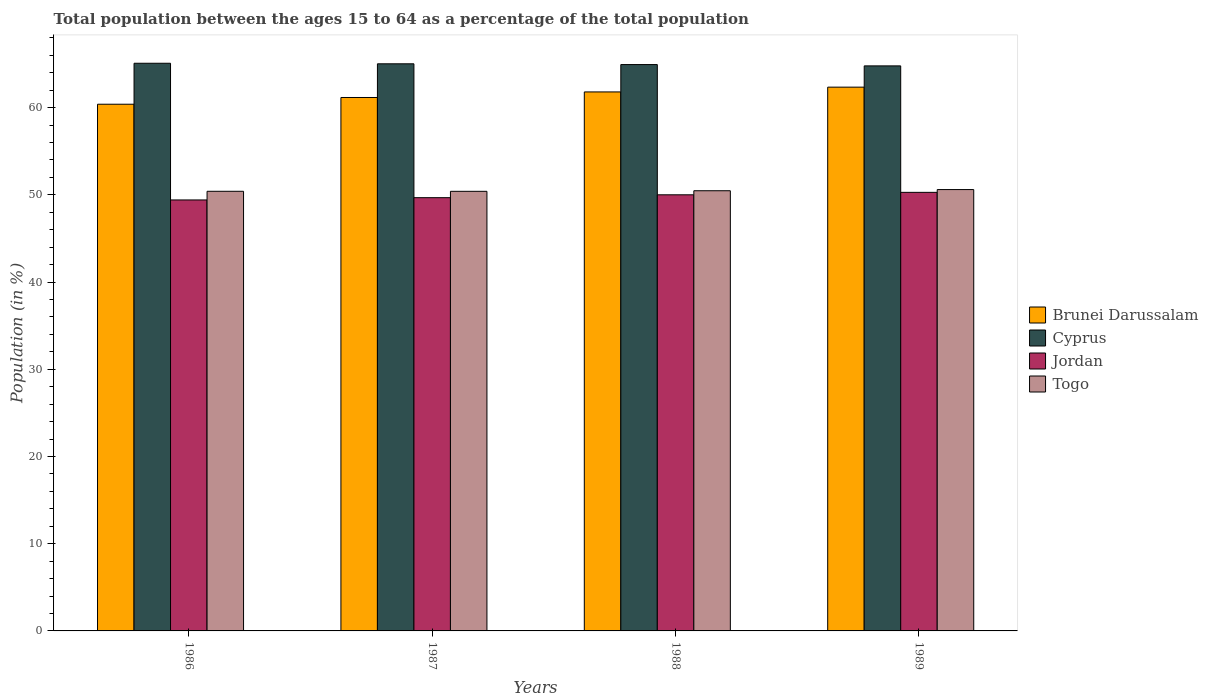How many different coloured bars are there?
Provide a short and direct response. 4. How many groups of bars are there?
Provide a short and direct response. 4. Are the number of bars on each tick of the X-axis equal?
Offer a terse response. Yes. What is the label of the 3rd group of bars from the left?
Keep it short and to the point. 1988. What is the percentage of the population ages 15 to 64 in Togo in 1986?
Make the answer very short. 50.4. Across all years, what is the maximum percentage of the population ages 15 to 64 in Jordan?
Ensure brevity in your answer.  50.28. Across all years, what is the minimum percentage of the population ages 15 to 64 in Jordan?
Offer a terse response. 49.41. In which year was the percentage of the population ages 15 to 64 in Togo minimum?
Your response must be concise. 1987. What is the total percentage of the population ages 15 to 64 in Togo in the graph?
Your response must be concise. 201.87. What is the difference between the percentage of the population ages 15 to 64 in Togo in 1987 and that in 1988?
Offer a very short reply. -0.07. What is the difference between the percentage of the population ages 15 to 64 in Brunei Darussalam in 1986 and the percentage of the population ages 15 to 64 in Togo in 1988?
Your answer should be very brief. 9.92. What is the average percentage of the population ages 15 to 64 in Jordan per year?
Provide a succinct answer. 49.84. In the year 1986, what is the difference between the percentage of the population ages 15 to 64 in Jordan and percentage of the population ages 15 to 64 in Togo?
Offer a terse response. -0.99. What is the ratio of the percentage of the population ages 15 to 64 in Brunei Darussalam in 1987 to that in 1988?
Offer a very short reply. 0.99. Is the percentage of the population ages 15 to 64 in Jordan in 1986 less than that in 1988?
Provide a short and direct response. Yes. What is the difference between the highest and the second highest percentage of the population ages 15 to 64 in Jordan?
Your answer should be very brief. 0.28. What is the difference between the highest and the lowest percentage of the population ages 15 to 64 in Jordan?
Offer a terse response. 0.87. In how many years, is the percentage of the population ages 15 to 64 in Jordan greater than the average percentage of the population ages 15 to 64 in Jordan taken over all years?
Offer a terse response. 2. Is it the case that in every year, the sum of the percentage of the population ages 15 to 64 in Jordan and percentage of the population ages 15 to 64 in Brunei Darussalam is greater than the sum of percentage of the population ages 15 to 64 in Togo and percentage of the population ages 15 to 64 in Cyprus?
Keep it short and to the point. Yes. What does the 2nd bar from the left in 1988 represents?
Provide a short and direct response. Cyprus. What does the 2nd bar from the right in 1986 represents?
Offer a very short reply. Jordan. Is it the case that in every year, the sum of the percentage of the population ages 15 to 64 in Togo and percentage of the population ages 15 to 64 in Jordan is greater than the percentage of the population ages 15 to 64 in Brunei Darussalam?
Give a very brief answer. Yes. How many years are there in the graph?
Ensure brevity in your answer.  4. Are the values on the major ticks of Y-axis written in scientific E-notation?
Provide a succinct answer. No. Does the graph contain any zero values?
Give a very brief answer. No. Where does the legend appear in the graph?
Give a very brief answer. Center right. How many legend labels are there?
Ensure brevity in your answer.  4. How are the legend labels stacked?
Make the answer very short. Vertical. What is the title of the graph?
Offer a terse response. Total population between the ages 15 to 64 as a percentage of the total population. What is the label or title of the X-axis?
Give a very brief answer. Years. What is the label or title of the Y-axis?
Offer a very short reply. Population (in %). What is the Population (in %) of Brunei Darussalam in 1986?
Provide a succinct answer. 60.38. What is the Population (in %) of Cyprus in 1986?
Make the answer very short. 65.08. What is the Population (in %) in Jordan in 1986?
Ensure brevity in your answer.  49.41. What is the Population (in %) in Togo in 1986?
Keep it short and to the point. 50.4. What is the Population (in %) of Brunei Darussalam in 1987?
Provide a succinct answer. 61.16. What is the Population (in %) of Cyprus in 1987?
Offer a terse response. 65.02. What is the Population (in %) in Jordan in 1987?
Offer a terse response. 49.67. What is the Population (in %) of Togo in 1987?
Provide a succinct answer. 50.4. What is the Population (in %) in Brunei Darussalam in 1988?
Your response must be concise. 61.79. What is the Population (in %) in Cyprus in 1988?
Give a very brief answer. 64.93. What is the Population (in %) in Jordan in 1988?
Provide a short and direct response. 50. What is the Population (in %) in Togo in 1988?
Ensure brevity in your answer.  50.47. What is the Population (in %) in Brunei Darussalam in 1989?
Offer a very short reply. 62.34. What is the Population (in %) of Cyprus in 1989?
Your response must be concise. 64.78. What is the Population (in %) in Jordan in 1989?
Your response must be concise. 50.28. What is the Population (in %) of Togo in 1989?
Make the answer very short. 50.6. Across all years, what is the maximum Population (in %) in Brunei Darussalam?
Ensure brevity in your answer.  62.34. Across all years, what is the maximum Population (in %) of Cyprus?
Your response must be concise. 65.08. Across all years, what is the maximum Population (in %) of Jordan?
Keep it short and to the point. 50.28. Across all years, what is the maximum Population (in %) in Togo?
Your answer should be compact. 50.6. Across all years, what is the minimum Population (in %) of Brunei Darussalam?
Offer a terse response. 60.38. Across all years, what is the minimum Population (in %) in Cyprus?
Your response must be concise. 64.78. Across all years, what is the minimum Population (in %) of Jordan?
Keep it short and to the point. 49.41. Across all years, what is the minimum Population (in %) in Togo?
Give a very brief answer. 50.4. What is the total Population (in %) in Brunei Darussalam in the graph?
Ensure brevity in your answer.  245.68. What is the total Population (in %) of Cyprus in the graph?
Offer a terse response. 259.81. What is the total Population (in %) of Jordan in the graph?
Offer a terse response. 199.36. What is the total Population (in %) of Togo in the graph?
Offer a very short reply. 201.87. What is the difference between the Population (in %) of Brunei Darussalam in 1986 and that in 1987?
Keep it short and to the point. -0.77. What is the difference between the Population (in %) of Cyprus in 1986 and that in 1987?
Offer a terse response. 0.06. What is the difference between the Population (in %) in Jordan in 1986 and that in 1987?
Give a very brief answer. -0.26. What is the difference between the Population (in %) in Togo in 1986 and that in 1987?
Your response must be concise. 0. What is the difference between the Population (in %) in Brunei Darussalam in 1986 and that in 1988?
Your response must be concise. -1.41. What is the difference between the Population (in %) of Cyprus in 1986 and that in 1988?
Give a very brief answer. 0.15. What is the difference between the Population (in %) in Jordan in 1986 and that in 1988?
Give a very brief answer. -0.59. What is the difference between the Population (in %) of Togo in 1986 and that in 1988?
Keep it short and to the point. -0.06. What is the difference between the Population (in %) of Brunei Darussalam in 1986 and that in 1989?
Offer a terse response. -1.96. What is the difference between the Population (in %) in Cyprus in 1986 and that in 1989?
Give a very brief answer. 0.3. What is the difference between the Population (in %) in Jordan in 1986 and that in 1989?
Ensure brevity in your answer.  -0.87. What is the difference between the Population (in %) of Togo in 1986 and that in 1989?
Your answer should be compact. -0.2. What is the difference between the Population (in %) in Brunei Darussalam in 1987 and that in 1988?
Ensure brevity in your answer.  -0.64. What is the difference between the Population (in %) of Cyprus in 1987 and that in 1988?
Give a very brief answer. 0.09. What is the difference between the Population (in %) in Jordan in 1987 and that in 1988?
Ensure brevity in your answer.  -0.33. What is the difference between the Population (in %) in Togo in 1987 and that in 1988?
Ensure brevity in your answer.  -0.07. What is the difference between the Population (in %) in Brunei Darussalam in 1987 and that in 1989?
Offer a very short reply. -1.18. What is the difference between the Population (in %) of Cyprus in 1987 and that in 1989?
Provide a short and direct response. 0.24. What is the difference between the Population (in %) of Jordan in 1987 and that in 1989?
Your answer should be very brief. -0.61. What is the difference between the Population (in %) of Togo in 1987 and that in 1989?
Keep it short and to the point. -0.2. What is the difference between the Population (in %) of Brunei Darussalam in 1988 and that in 1989?
Offer a terse response. -0.55. What is the difference between the Population (in %) in Cyprus in 1988 and that in 1989?
Give a very brief answer. 0.15. What is the difference between the Population (in %) in Jordan in 1988 and that in 1989?
Provide a succinct answer. -0.28. What is the difference between the Population (in %) in Togo in 1988 and that in 1989?
Offer a very short reply. -0.13. What is the difference between the Population (in %) of Brunei Darussalam in 1986 and the Population (in %) of Cyprus in 1987?
Keep it short and to the point. -4.64. What is the difference between the Population (in %) in Brunei Darussalam in 1986 and the Population (in %) in Jordan in 1987?
Your answer should be compact. 10.71. What is the difference between the Population (in %) of Brunei Darussalam in 1986 and the Population (in %) of Togo in 1987?
Provide a short and direct response. 9.98. What is the difference between the Population (in %) in Cyprus in 1986 and the Population (in %) in Jordan in 1987?
Your answer should be compact. 15.41. What is the difference between the Population (in %) in Cyprus in 1986 and the Population (in %) in Togo in 1987?
Provide a short and direct response. 14.68. What is the difference between the Population (in %) in Jordan in 1986 and the Population (in %) in Togo in 1987?
Give a very brief answer. -0.99. What is the difference between the Population (in %) in Brunei Darussalam in 1986 and the Population (in %) in Cyprus in 1988?
Your answer should be compact. -4.55. What is the difference between the Population (in %) of Brunei Darussalam in 1986 and the Population (in %) of Jordan in 1988?
Provide a succinct answer. 10.38. What is the difference between the Population (in %) of Brunei Darussalam in 1986 and the Population (in %) of Togo in 1988?
Offer a very short reply. 9.92. What is the difference between the Population (in %) in Cyprus in 1986 and the Population (in %) in Jordan in 1988?
Offer a terse response. 15.08. What is the difference between the Population (in %) in Cyprus in 1986 and the Population (in %) in Togo in 1988?
Ensure brevity in your answer.  14.62. What is the difference between the Population (in %) in Jordan in 1986 and the Population (in %) in Togo in 1988?
Provide a short and direct response. -1.06. What is the difference between the Population (in %) in Brunei Darussalam in 1986 and the Population (in %) in Cyprus in 1989?
Offer a very short reply. -4.4. What is the difference between the Population (in %) in Brunei Darussalam in 1986 and the Population (in %) in Jordan in 1989?
Offer a terse response. 10.1. What is the difference between the Population (in %) in Brunei Darussalam in 1986 and the Population (in %) in Togo in 1989?
Ensure brevity in your answer.  9.78. What is the difference between the Population (in %) of Cyprus in 1986 and the Population (in %) of Jordan in 1989?
Make the answer very short. 14.8. What is the difference between the Population (in %) in Cyprus in 1986 and the Population (in %) in Togo in 1989?
Your answer should be very brief. 14.48. What is the difference between the Population (in %) in Jordan in 1986 and the Population (in %) in Togo in 1989?
Offer a very short reply. -1.19. What is the difference between the Population (in %) in Brunei Darussalam in 1987 and the Population (in %) in Cyprus in 1988?
Provide a succinct answer. -3.77. What is the difference between the Population (in %) of Brunei Darussalam in 1987 and the Population (in %) of Jordan in 1988?
Ensure brevity in your answer.  11.16. What is the difference between the Population (in %) in Brunei Darussalam in 1987 and the Population (in %) in Togo in 1988?
Keep it short and to the point. 10.69. What is the difference between the Population (in %) in Cyprus in 1987 and the Population (in %) in Jordan in 1988?
Your answer should be very brief. 15.02. What is the difference between the Population (in %) in Cyprus in 1987 and the Population (in %) in Togo in 1988?
Provide a succinct answer. 14.55. What is the difference between the Population (in %) of Jordan in 1987 and the Population (in %) of Togo in 1988?
Ensure brevity in your answer.  -0.79. What is the difference between the Population (in %) of Brunei Darussalam in 1987 and the Population (in %) of Cyprus in 1989?
Give a very brief answer. -3.62. What is the difference between the Population (in %) in Brunei Darussalam in 1987 and the Population (in %) in Jordan in 1989?
Give a very brief answer. 10.88. What is the difference between the Population (in %) in Brunei Darussalam in 1987 and the Population (in %) in Togo in 1989?
Provide a succinct answer. 10.56. What is the difference between the Population (in %) of Cyprus in 1987 and the Population (in %) of Jordan in 1989?
Your response must be concise. 14.74. What is the difference between the Population (in %) in Cyprus in 1987 and the Population (in %) in Togo in 1989?
Give a very brief answer. 14.42. What is the difference between the Population (in %) in Jordan in 1987 and the Population (in %) in Togo in 1989?
Provide a succinct answer. -0.93. What is the difference between the Population (in %) in Brunei Darussalam in 1988 and the Population (in %) in Cyprus in 1989?
Ensure brevity in your answer.  -2.99. What is the difference between the Population (in %) in Brunei Darussalam in 1988 and the Population (in %) in Jordan in 1989?
Keep it short and to the point. 11.51. What is the difference between the Population (in %) of Brunei Darussalam in 1988 and the Population (in %) of Togo in 1989?
Keep it short and to the point. 11.19. What is the difference between the Population (in %) of Cyprus in 1988 and the Population (in %) of Jordan in 1989?
Ensure brevity in your answer.  14.65. What is the difference between the Population (in %) in Cyprus in 1988 and the Population (in %) in Togo in 1989?
Provide a succinct answer. 14.33. What is the difference between the Population (in %) in Jordan in 1988 and the Population (in %) in Togo in 1989?
Ensure brevity in your answer.  -0.6. What is the average Population (in %) of Brunei Darussalam per year?
Ensure brevity in your answer.  61.42. What is the average Population (in %) in Cyprus per year?
Provide a short and direct response. 64.95. What is the average Population (in %) of Jordan per year?
Provide a short and direct response. 49.84. What is the average Population (in %) in Togo per year?
Provide a succinct answer. 50.47. In the year 1986, what is the difference between the Population (in %) of Brunei Darussalam and Population (in %) of Cyprus?
Offer a terse response. -4.7. In the year 1986, what is the difference between the Population (in %) in Brunei Darussalam and Population (in %) in Jordan?
Make the answer very short. 10.97. In the year 1986, what is the difference between the Population (in %) in Brunei Darussalam and Population (in %) in Togo?
Your answer should be very brief. 9.98. In the year 1986, what is the difference between the Population (in %) in Cyprus and Population (in %) in Jordan?
Provide a succinct answer. 15.67. In the year 1986, what is the difference between the Population (in %) of Cyprus and Population (in %) of Togo?
Ensure brevity in your answer.  14.68. In the year 1986, what is the difference between the Population (in %) of Jordan and Population (in %) of Togo?
Give a very brief answer. -0.99. In the year 1987, what is the difference between the Population (in %) in Brunei Darussalam and Population (in %) in Cyprus?
Your answer should be compact. -3.86. In the year 1987, what is the difference between the Population (in %) of Brunei Darussalam and Population (in %) of Jordan?
Your response must be concise. 11.49. In the year 1987, what is the difference between the Population (in %) in Brunei Darussalam and Population (in %) in Togo?
Ensure brevity in your answer.  10.76. In the year 1987, what is the difference between the Population (in %) in Cyprus and Population (in %) in Jordan?
Offer a very short reply. 15.35. In the year 1987, what is the difference between the Population (in %) of Cyprus and Population (in %) of Togo?
Offer a terse response. 14.62. In the year 1987, what is the difference between the Population (in %) of Jordan and Population (in %) of Togo?
Provide a succinct answer. -0.73. In the year 1988, what is the difference between the Population (in %) in Brunei Darussalam and Population (in %) in Cyprus?
Give a very brief answer. -3.14. In the year 1988, what is the difference between the Population (in %) in Brunei Darussalam and Population (in %) in Jordan?
Ensure brevity in your answer.  11.79. In the year 1988, what is the difference between the Population (in %) in Brunei Darussalam and Population (in %) in Togo?
Your answer should be very brief. 11.33. In the year 1988, what is the difference between the Population (in %) in Cyprus and Population (in %) in Jordan?
Provide a short and direct response. 14.93. In the year 1988, what is the difference between the Population (in %) of Cyprus and Population (in %) of Togo?
Provide a short and direct response. 14.47. In the year 1988, what is the difference between the Population (in %) in Jordan and Population (in %) in Togo?
Provide a short and direct response. -0.47. In the year 1989, what is the difference between the Population (in %) of Brunei Darussalam and Population (in %) of Cyprus?
Provide a short and direct response. -2.44. In the year 1989, what is the difference between the Population (in %) of Brunei Darussalam and Population (in %) of Jordan?
Provide a short and direct response. 12.06. In the year 1989, what is the difference between the Population (in %) in Brunei Darussalam and Population (in %) in Togo?
Your response must be concise. 11.74. In the year 1989, what is the difference between the Population (in %) in Cyprus and Population (in %) in Jordan?
Ensure brevity in your answer.  14.5. In the year 1989, what is the difference between the Population (in %) of Cyprus and Population (in %) of Togo?
Your answer should be compact. 14.18. In the year 1989, what is the difference between the Population (in %) of Jordan and Population (in %) of Togo?
Your answer should be very brief. -0.32. What is the ratio of the Population (in %) in Brunei Darussalam in 1986 to that in 1987?
Give a very brief answer. 0.99. What is the ratio of the Population (in %) of Jordan in 1986 to that in 1987?
Your response must be concise. 0.99. What is the ratio of the Population (in %) of Brunei Darussalam in 1986 to that in 1988?
Offer a very short reply. 0.98. What is the ratio of the Population (in %) in Cyprus in 1986 to that in 1988?
Ensure brevity in your answer.  1. What is the ratio of the Population (in %) in Jordan in 1986 to that in 1988?
Give a very brief answer. 0.99. What is the ratio of the Population (in %) of Brunei Darussalam in 1986 to that in 1989?
Provide a short and direct response. 0.97. What is the ratio of the Population (in %) of Cyprus in 1986 to that in 1989?
Your answer should be compact. 1. What is the ratio of the Population (in %) of Jordan in 1986 to that in 1989?
Your answer should be compact. 0.98. What is the ratio of the Population (in %) in Jordan in 1987 to that in 1988?
Give a very brief answer. 0.99. What is the ratio of the Population (in %) of Togo in 1987 to that in 1988?
Make the answer very short. 1. What is the ratio of the Population (in %) of Brunei Darussalam in 1987 to that in 1989?
Make the answer very short. 0.98. What is the ratio of the Population (in %) of Jordan in 1987 to that in 1989?
Your response must be concise. 0.99. What is the ratio of the Population (in %) in Brunei Darussalam in 1988 to that in 1989?
Offer a terse response. 0.99. What is the difference between the highest and the second highest Population (in %) of Brunei Darussalam?
Your answer should be compact. 0.55. What is the difference between the highest and the second highest Population (in %) in Cyprus?
Your response must be concise. 0.06. What is the difference between the highest and the second highest Population (in %) of Jordan?
Your response must be concise. 0.28. What is the difference between the highest and the second highest Population (in %) in Togo?
Keep it short and to the point. 0.13. What is the difference between the highest and the lowest Population (in %) of Brunei Darussalam?
Provide a short and direct response. 1.96. What is the difference between the highest and the lowest Population (in %) of Cyprus?
Give a very brief answer. 0.3. What is the difference between the highest and the lowest Population (in %) of Jordan?
Provide a succinct answer. 0.87. What is the difference between the highest and the lowest Population (in %) of Togo?
Make the answer very short. 0.2. 